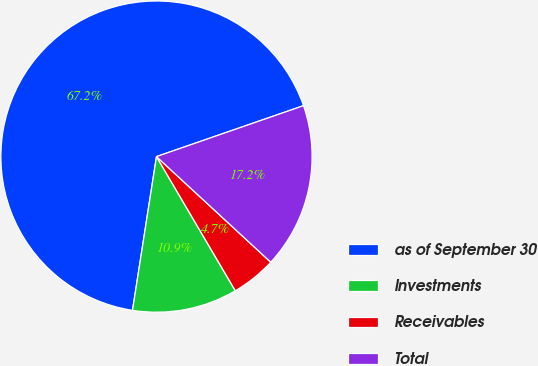Convert chart. <chart><loc_0><loc_0><loc_500><loc_500><pie_chart><fcel>as of September 30<fcel>Investments<fcel>Receivables<fcel>Total<nl><fcel>67.23%<fcel>10.92%<fcel>4.67%<fcel>17.18%<nl></chart> 